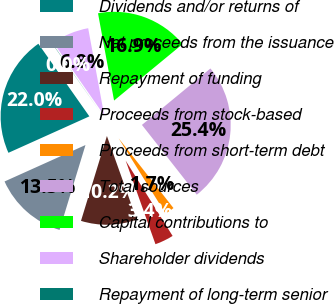<chart> <loc_0><loc_0><loc_500><loc_500><pie_chart><fcel>Dividends and/or returns of<fcel>Net proceeds from the issuance<fcel>Repayment of funding<fcel>Proceeds from stock-based<fcel>Proceeds from short-term debt<fcel>Total sources<fcel>Capital contributions to<fcel>Shareholder dividends<fcel>Repayment of long-term senior<nl><fcel>21.99%<fcel>13.55%<fcel>10.17%<fcel>3.42%<fcel>1.73%<fcel>25.37%<fcel>16.93%<fcel>6.8%<fcel>0.05%<nl></chart> 